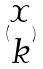<formula> <loc_0><loc_0><loc_500><loc_500>( \begin{matrix} x \\ k \end{matrix} )</formula> 